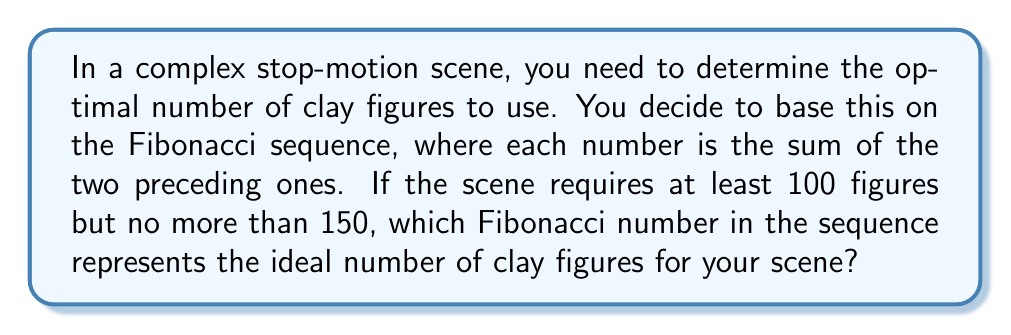Can you solve this math problem? Let's approach this step-by-step:

1) First, let's recall the Fibonacci sequence:
   $$F_n = F_{n-1} + F_{n-2}$$
   where $F_1 = 1$ and $F_2 = 1$

2) Let's generate the Fibonacci sequence until we exceed 150:
   $$F_1 = 1$$
   $$F_2 = 1$$
   $$F_3 = 1 + 1 = 2$$
   $$F_4 = 2 + 1 = 3$$
   $$F_5 = 3 + 2 = 5$$
   $$F_6 = 5 + 3 = 8$$
   $$F_7 = 8 + 5 = 13$$
   $$F_8 = 13 + 8 = 21$$
   $$F_9 = 21 + 13 = 34$$
   $$F_{10} = 34 + 21 = 55$$
   $$F_{11} = 55 + 34 = 89$$
   $$F_{12} = 89 + 55 = 144$$
   $$F_{13} = 144 + 89 = 233$$ (exceeds 150)

3) From this sequence, we can see that $F_{12} = 144$ is the only Fibonacci number that falls within our range of 100 to 150.

4) Therefore, the 12th Fibonacci number, 144, represents the ideal number of clay figures for the scene.
Answer: 12th Fibonacci number (144) 